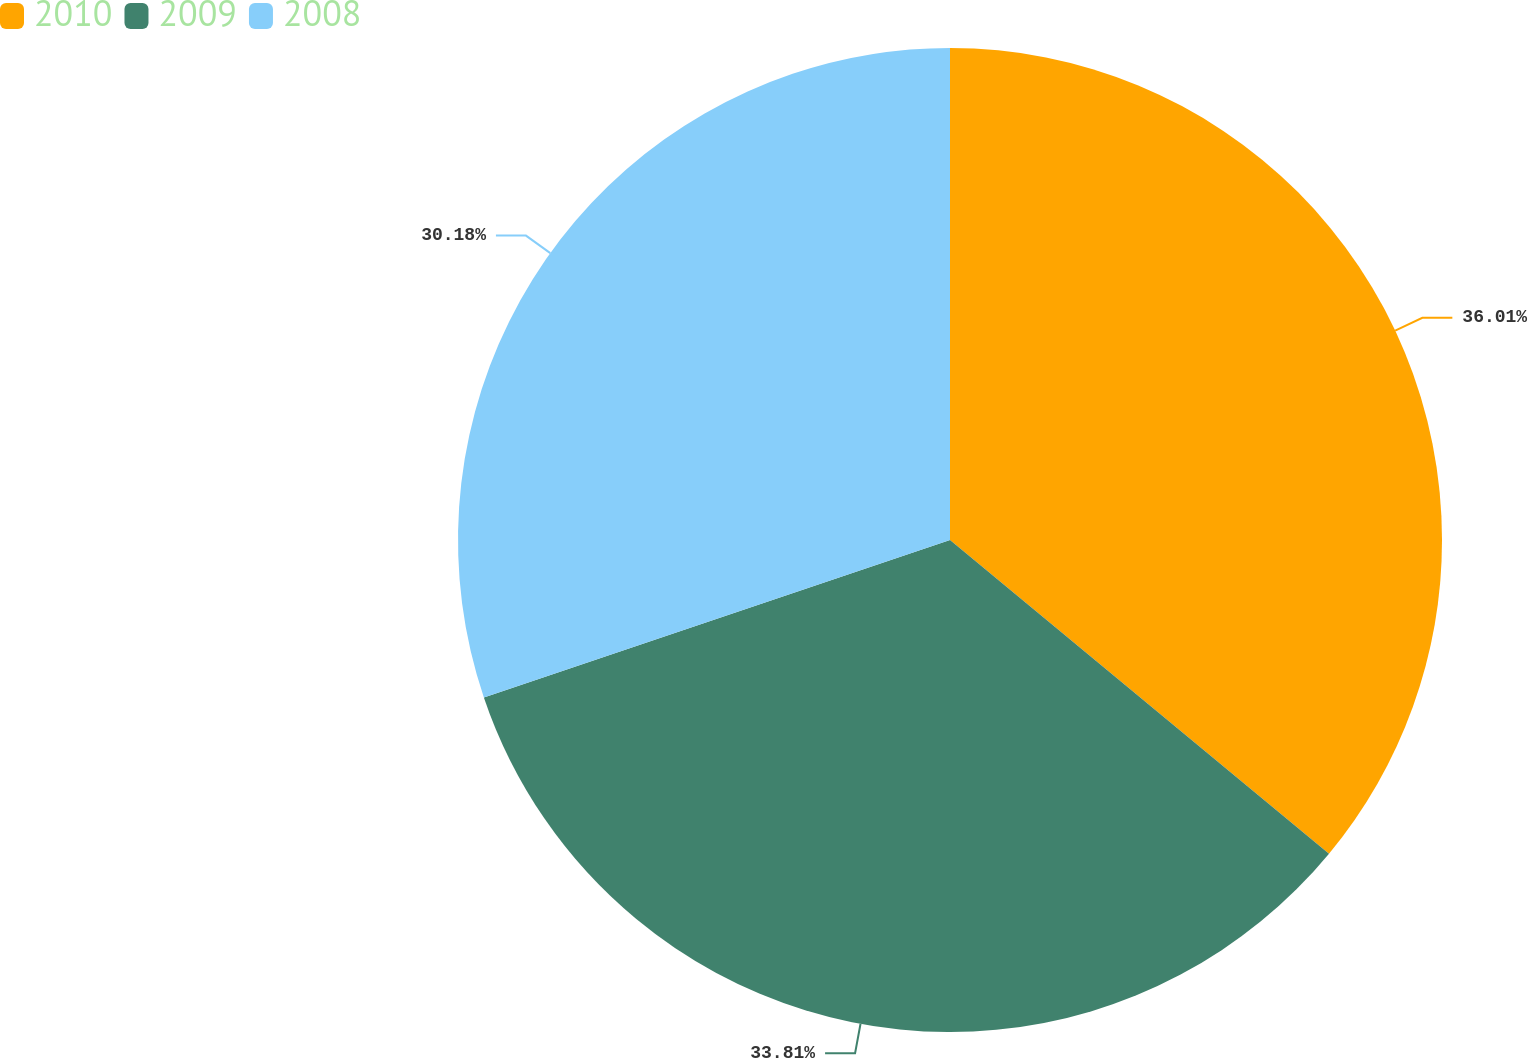Convert chart to OTSL. <chart><loc_0><loc_0><loc_500><loc_500><pie_chart><fcel>2010<fcel>2009<fcel>2008<nl><fcel>36.0%<fcel>33.81%<fcel>30.18%<nl></chart> 